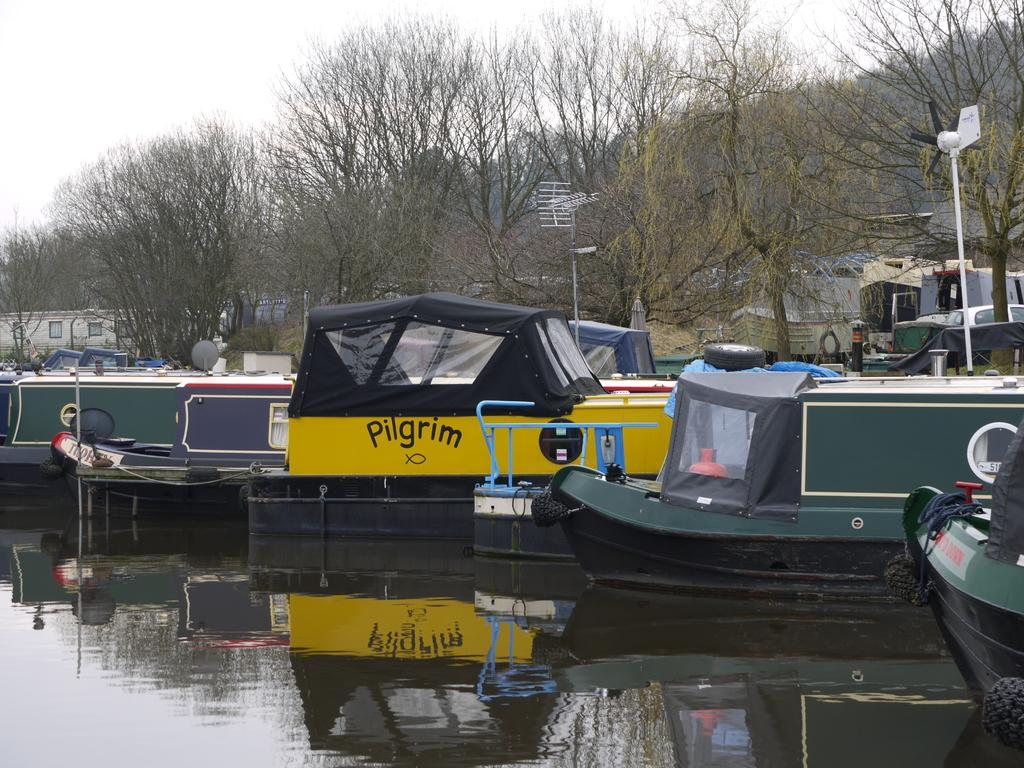What is located in the middle of the image? There are boats in the middle of the image. What is visible at the bottom of the image? There is water visible at the bottom of the image. What type of vegetation can be seen in the middle of the image? There are trees in the middle of the image. What is visible at the top of the image? There is sky visible at the top of the image. What type of wood can be seen in the image? There is no wood present in the image; it features boats, water, trees, and sky. Is there an arch visible in the image? There is no arch present in the image. 